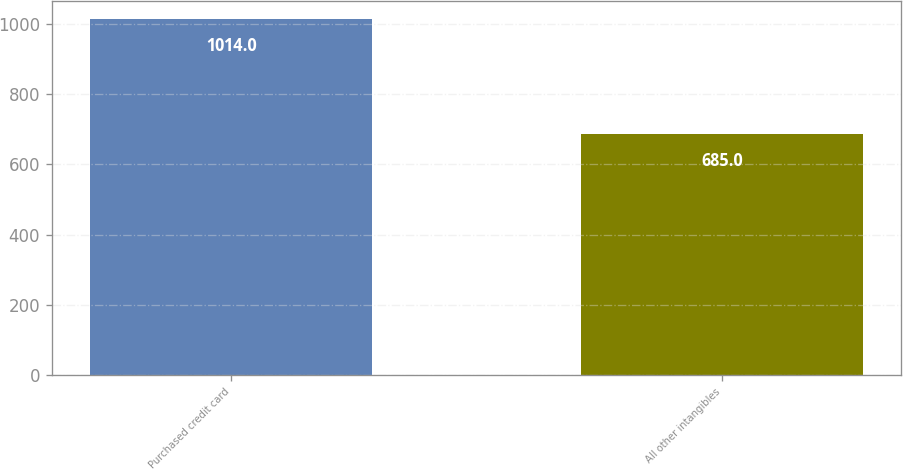Convert chart to OTSL. <chart><loc_0><loc_0><loc_500><loc_500><bar_chart><fcel>Purchased credit card<fcel>All other intangibles<nl><fcel>1014<fcel>685<nl></chart> 